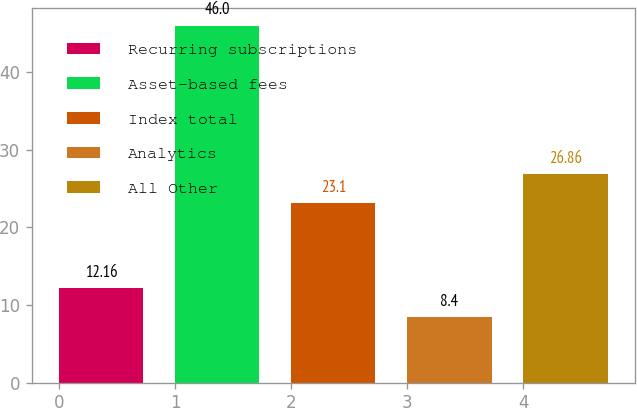<chart> <loc_0><loc_0><loc_500><loc_500><bar_chart><fcel>Recurring subscriptions<fcel>Asset-based fees<fcel>Index total<fcel>Analytics<fcel>All Other<nl><fcel>12.16<fcel>46<fcel>23.1<fcel>8.4<fcel>26.86<nl></chart> 